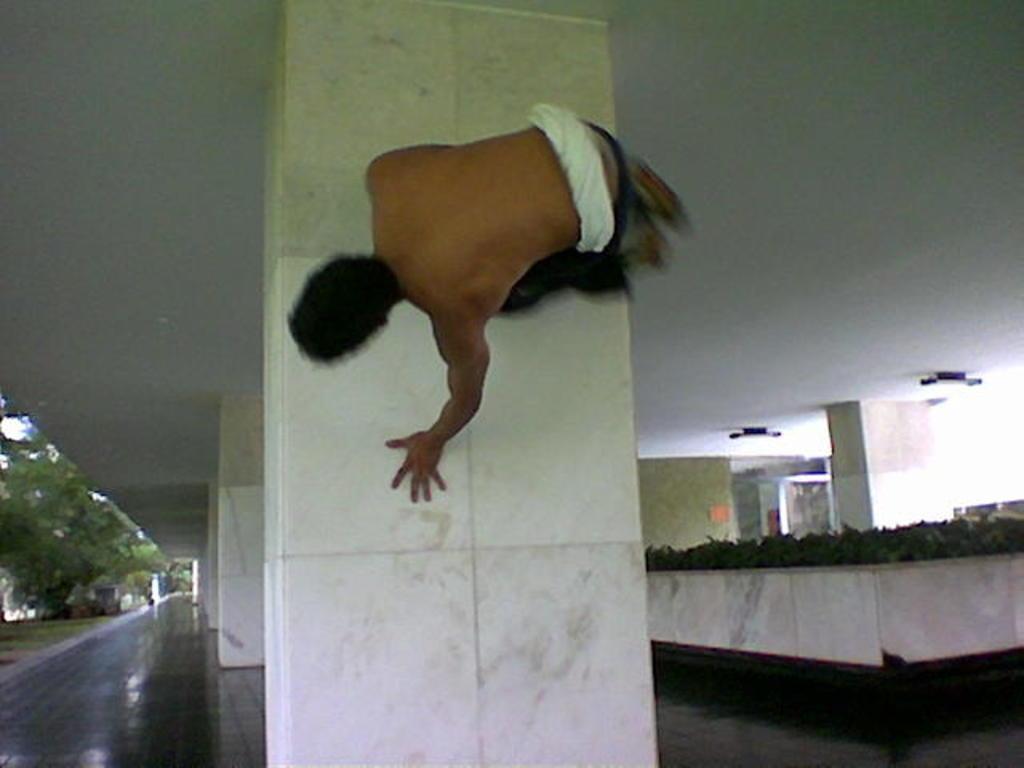How would you summarize this image in a sentence or two? In this image I can see a man and number of pillars in the centre. On the left side of this image I can see number of trees and on the right side I can see few black colour things on the ceiling. 